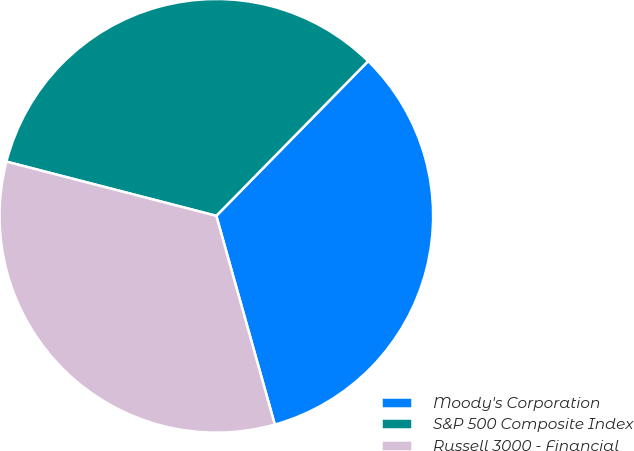Convert chart to OTSL. <chart><loc_0><loc_0><loc_500><loc_500><pie_chart><fcel>Moody's Corporation<fcel>S&P 500 Composite Index<fcel>Russell 3000 - Financial<nl><fcel>33.3%<fcel>33.33%<fcel>33.37%<nl></chart> 